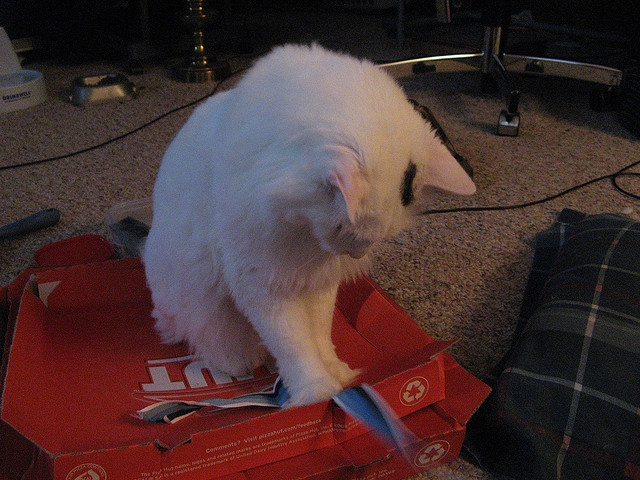Describe the objects in this image and their specific colors. I can see cat in black, gray, and darkgray tones, chair in black, maroon, darkgreen, and gray tones, and bowl in black, olive, and brown tones in this image. 